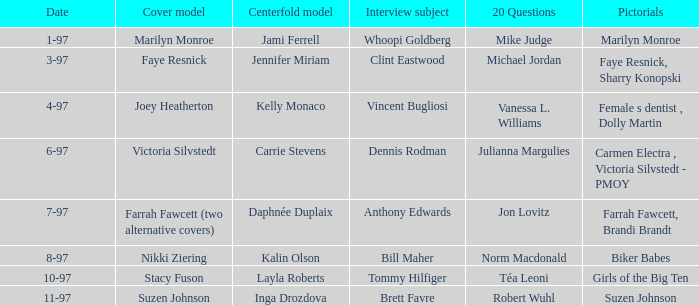When was kalin olson designated as the centerfold model? 8-97. 